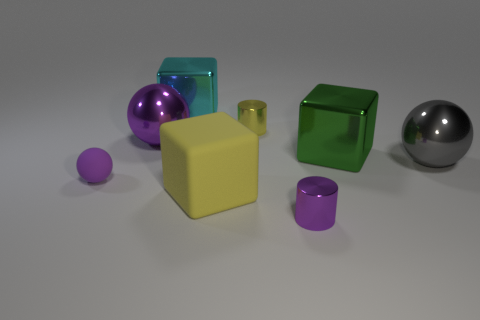What color is the other matte thing that is the same shape as the big purple thing?
Offer a terse response. Purple. There is a cube that is both behind the big gray object and in front of the large purple shiny sphere; how big is it?
Ensure brevity in your answer.  Large. Is there a large purple sphere made of the same material as the large gray sphere?
Give a very brief answer. Yes. What number of things are cyan matte cylinders or green objects?
Give a very brief answer. 1. Are the green cube and the cylinder that is in front of the big purple shiny thing made of the same material?
Keep it short and to the point. Yes. There is a purple ball that is behind the small purple matte thing; what is its size?
Make the answer very short. Large. Are there fewer purple metal things than large blue metallic blocks?
Provide a succinct answer. No. Are there any tiny cylinders of the same color as the large matte object?
Provide a short and direct response. Yes. There is a object that is behind the large purple ball and in front of the large cyan block; what is its shape?
Your answer should be compact. Cylinder. There is a big gray metallic object that is in front of the large object that is behind the large purple shiny ball; what shape is it?
Your answer should be compact. Sphere. 